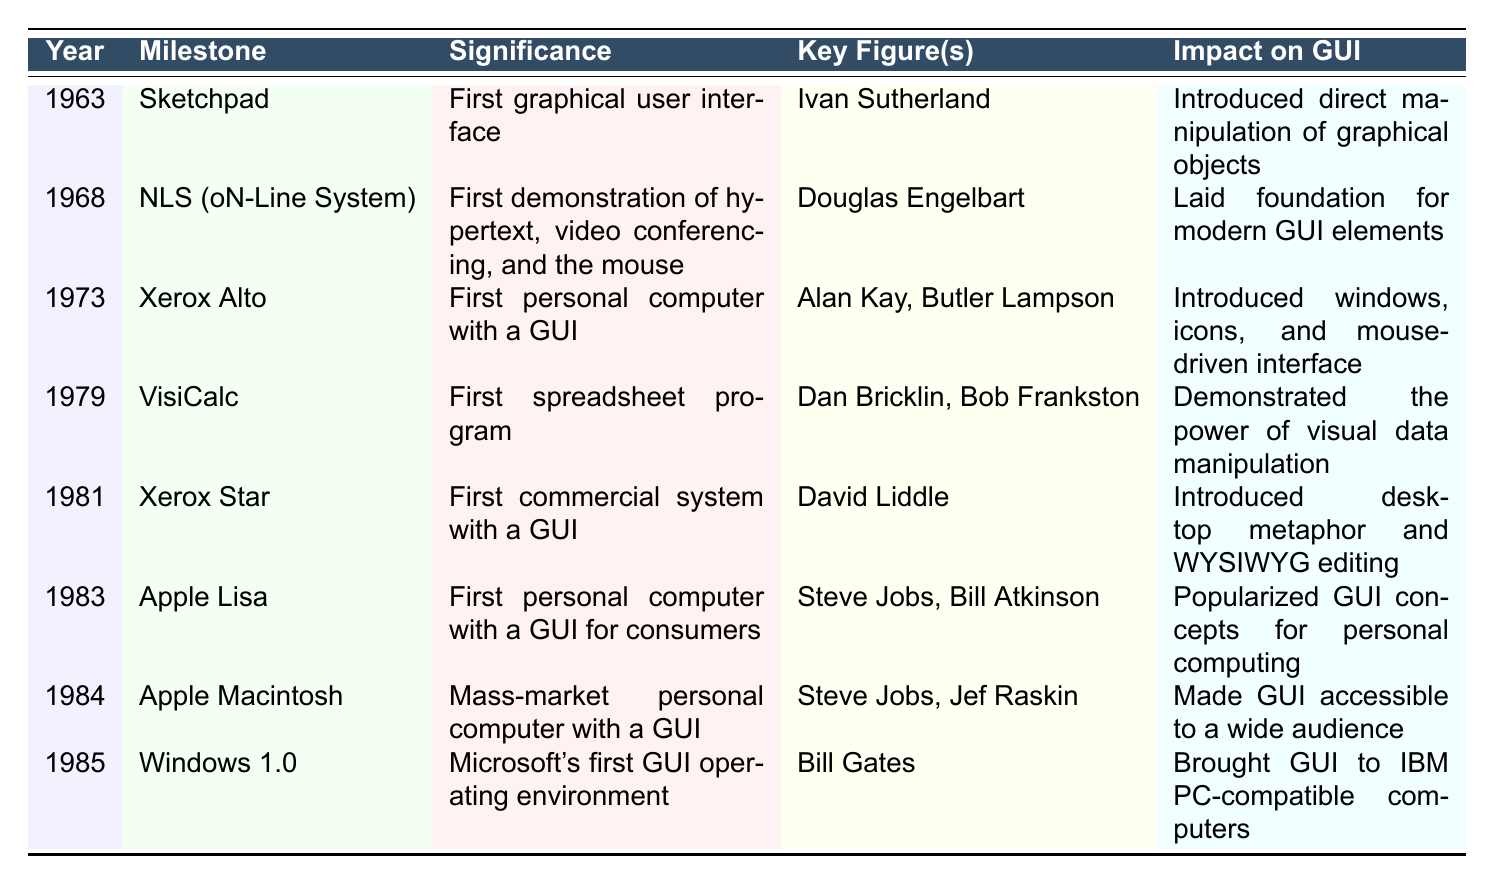What year was the first graphical user interface introduced? The first graphical user interface, Sketchpad, was introduced in the year 1963 according to the table.
Answer: 1963 Who were the key figures involved in the development of the Xerox Alto? The table lists Alan Kay and Butler Lampson as the key figures involved in the development of the Xerox Alto.
Answer: Alan Kay, Butler Lampson Which milestone represented the first mass-market personal computer with a GUI? According to the table, the Apple Macintosh, introduced in 1984, was the first mass-market personal computer with a GUI.
Answer: Apple Macintosh What significance did the NLS (oN-Line System) hold in the context of human-computer interaction? The NLS demonstrated hypertext, video conferencing, and the mouse in 1968, thus marking an important milestone in human-computer interaction.
Answer: First demonstration of hypertext, video conferencing, and the mouse Which milestone introduced the desktop metaphor and what was its year? The Xerox Star introduced the desktop metaphor in the year 1981 as per the details in the table.
Answer: 1981 How many years passed between the introduction of the first spreadsheet program and the first commercial system with a GUI? VisiCalc was introduced in 1979 and the Xerox Star in 1981, so the difference is 1981 - 1979 = 2 years.
Answer: 2 years Is it true that the Apple Lisa was the first personal computer with a GUI for consumers? Yes, the table states that the Apple Lisa was introduced as the first personal computer with a GUI for consumers in 1983.
Answer: True What impact did the Xerox Alto have on graphical user interfaces? The Xerox Alto introduced the concepts of windows, icons, and a mouse-driven interface, significantly impacting graphical user interfaces as noted in the table.
Answer: Introduced windows, icons, and mouse-driven interface Which two milestones were introduced by Steve Jobs, and in what years? The Apple Lisa (1983) and Apple Macintosh (1984) were both milestones created by Steve Jobs, according to the table.
Answer: Apple Lisa (1983), Apple Macintosh (1984) Determine the chronological order of milestones introduced between 1963 and 1985. The chronological order based on the years is: Sketchpad (1963), NLS (1968), Xerox Alto (1973), VisiCalc (1979), Xerox Star (1981), Apple Lisa (1983), Apple Macintosh (1984), and Windows 1.0 (1985).
Answer: Sketchpad, NLS, Xerox Alto, VisiCalc, Xerox Star, Apple Lisa, Apple Macintosh, Windows 1.0 